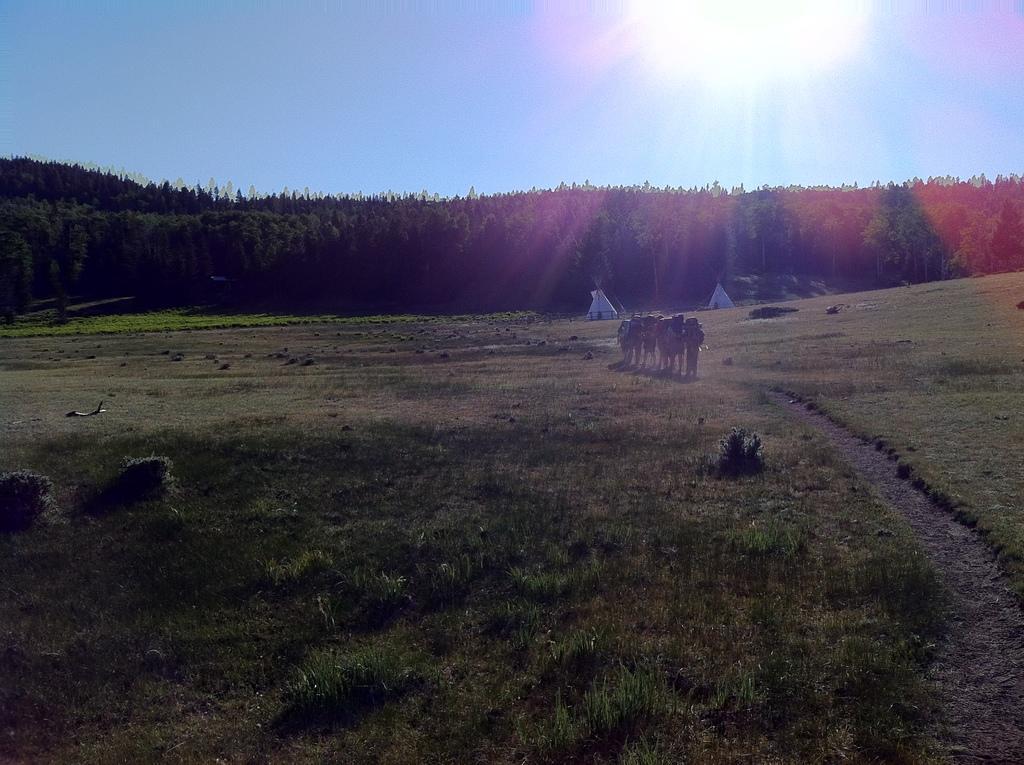In one or two sentences, can you explain what this image depicts? In this image I can see group of people standing, background I can see trees in green color and the sky is in blue color. 